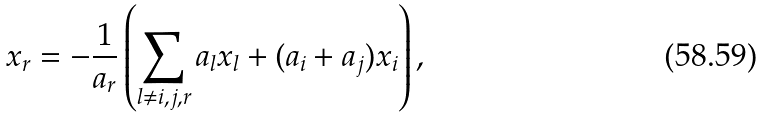<formula> <loc_0><loc_0><loc_500><loc_500>x _ { r } = - \frac { 1 } { a _ { r } } \left ( \sum _ { l \neq i , j , r } a _ { l } x _ { l } + ( a _ { i } + a _ { j } ) x _ { i } \right ) ,</formula> 